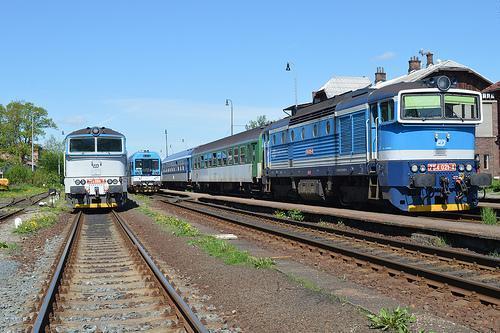How many trains are there?
Give a very brief answer. 3. 